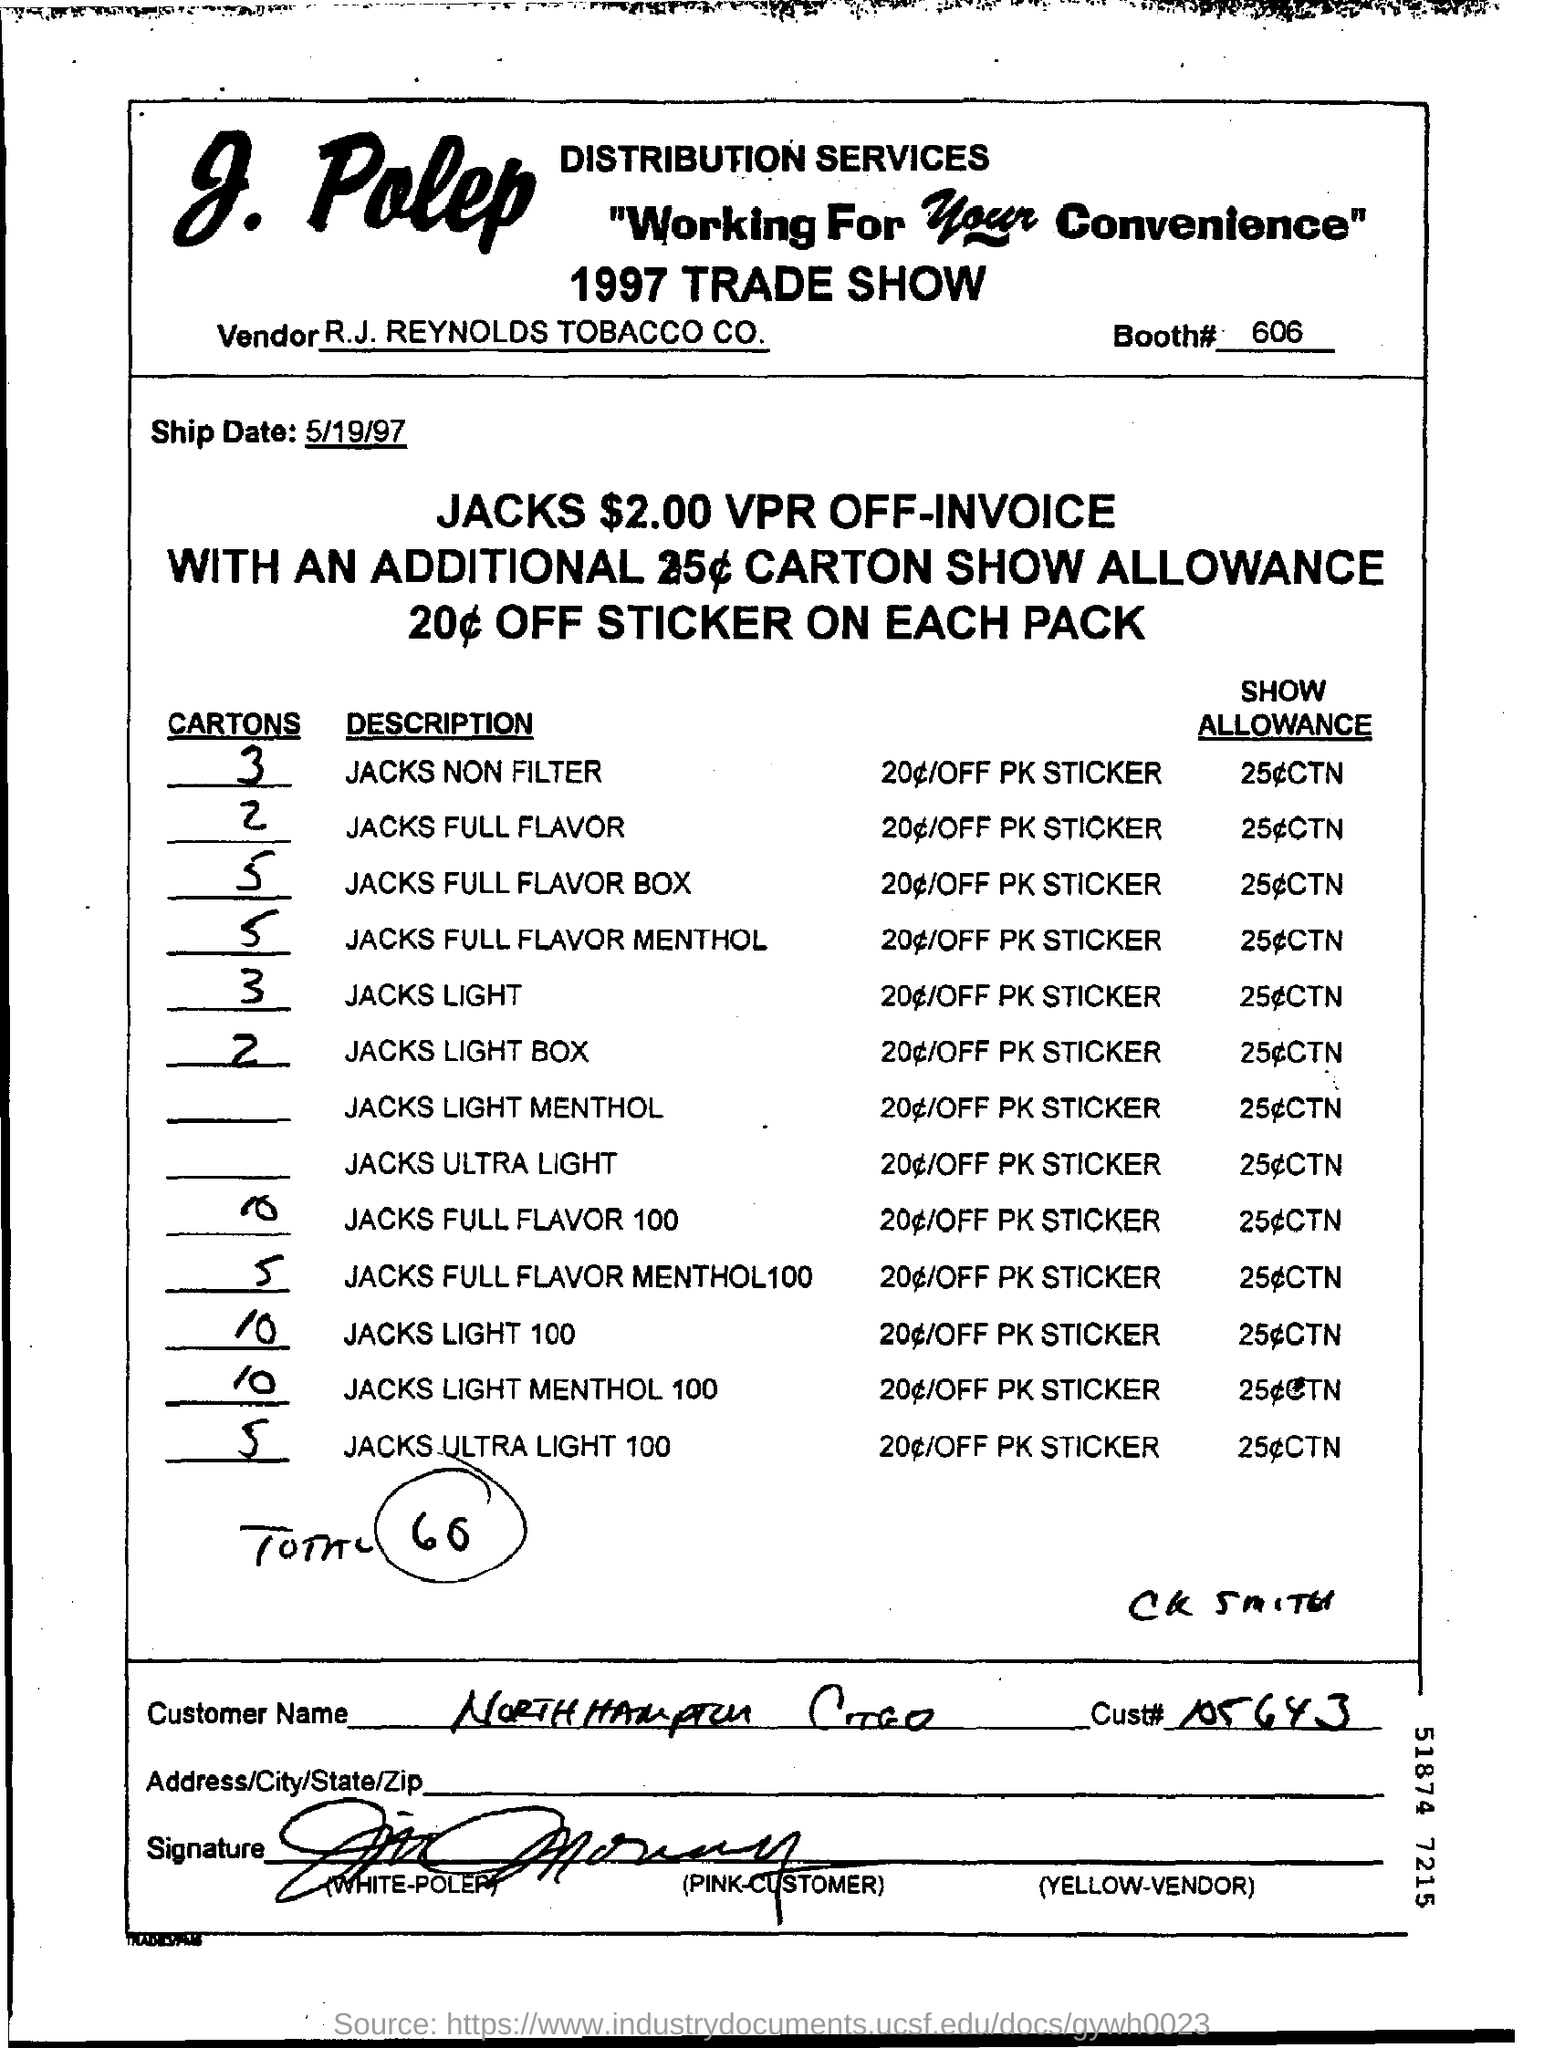What is the name of the vendor mentioned ?
Your answer should be compact. R.J. REYNOLDS TOBACCO Co. What is the booth no. mentioned ?
Ensure brevity in your answer.  606. What is the ship date mentioned ?
Ensure brevity in your answer.  5/19/97. What is the no. of jacks non filter cartons mentioned ?
Provide a short and direct response. 3. How many no. of jacks full flavor cartons are mentioned ?
Offer a terse response. 2. 